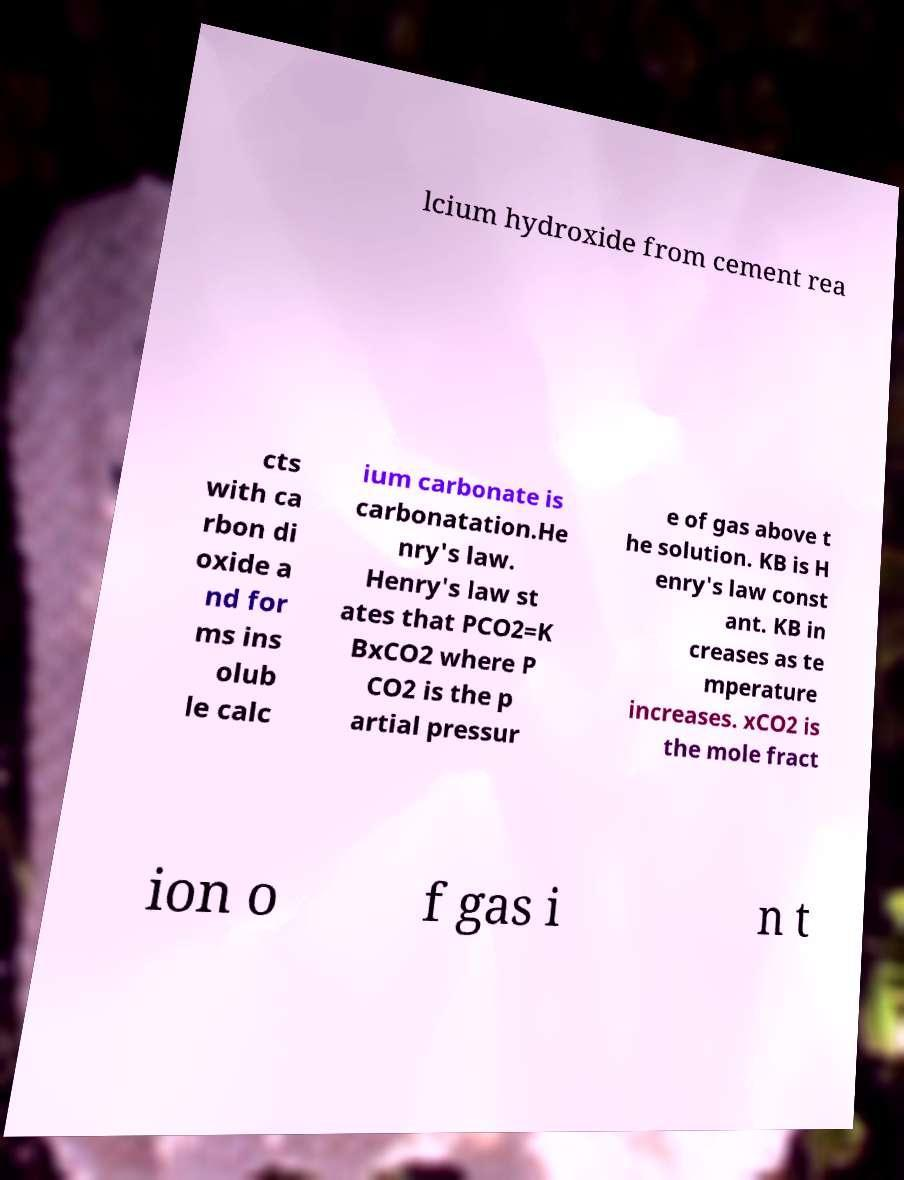Could you extract and type out the text from this image? lcium hydroxide from cement rea cts with ca rbon di oxide a nd for ms ins olub le calc ium carbonate is carbonatation.He nry's law. Henry's law st ates that PCO2=K BxCO2 where P CO2 is the p artial pressur e of gas above t he solution. KB is H enry's law const ant. KB in creases as te mperature increases. xCO2 is the mole fract ion o f gas i n t 